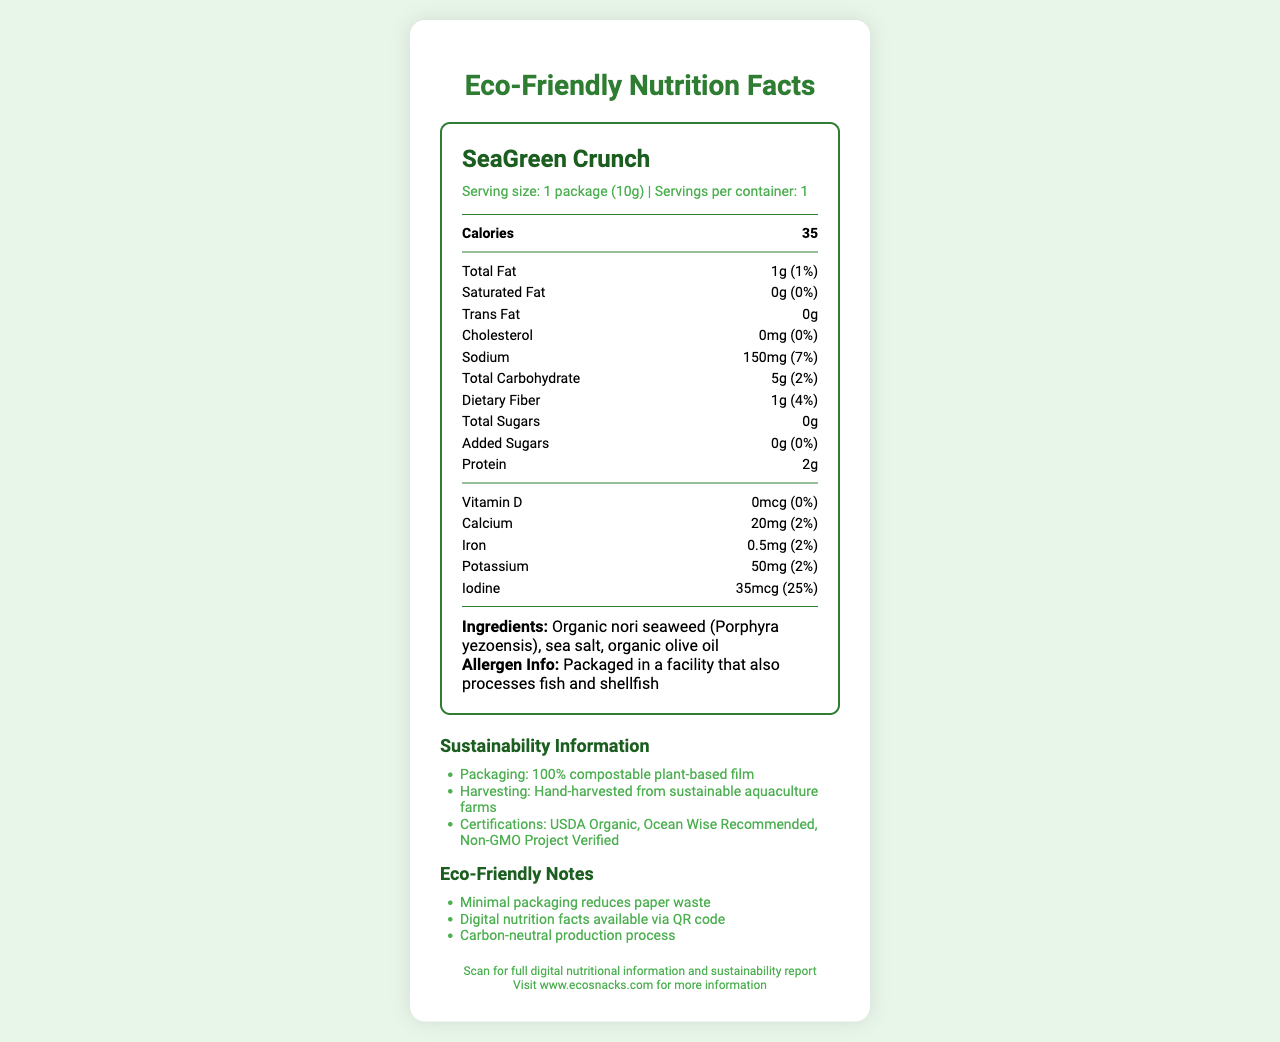What is the serving size of SeaGreen Crunch? The serving size is stated at the beginning of the document: "Serving size: 1 package (10g)."
Answer: 1 package (10g) How many calories does one serving of SeaGreen Crunch have? The calories amount is provided in the nutrients section: "Calories 35."
Answer: 35 calories How much sodium is in one serving of SeaGreen Crunch? The sodium content is detailed in the nutrients section: "Sodium 150mg (7%)."
Answer: 150mg What are the main ingredients in SeaGreen Crunch? The ingredients list states: "Ingredients: Organic nori seaweed (Porphyra yezoensis), sea salt, organic olive oil."
Answer: Organic nori seaweed (Porphyra yezoensis), sea salt, organic olive oil Does SeaGreen Crunch contain any added sugars? The label specifies: "Added Sugars: 0g (0%)."
Answer: No What is the daily value of iron in SeaGreen Crunch? A. 0% B. 2% C. 7% D. 4% The nutrients section lists iron with a daily value of 2%, thus option B is correct: "Iron 0.5mg (2%)."
Answer: B. 2% Which of the following certifications does SeaGreen Crunch have? I. USDA Organic II. Fair Trade III. Ocean Wise Recommended IV. Non-GMO Project Verified SeaGreen Crunch has the certifications "USDA Organic", "Ocean Wise Recommended", and "Non-GMO Project Verified."
Answer: I, III, IV Is the packaging of SeaGreen Crunch compostable? The sustainability information section mentions: "Packaging: 100% compostable plant-based film."
Answer: Yes Summarize the main purpose of this document. This document details the nutritional contents of SeaGreen Crunch, including calories, fats, sodium, carbohydrates, fiber, and sugars. It also lists ingredients, allergen information, and certifications such as USDA Organic and Non-GMO Project Verified. Additionally, the document emphasizes the product's eco-friendly aspects, like compostable packaging and carbon-neutral production.
Answer: It provides the nutritional facts and sustainability information for SeaGreen Crunch, highlighting its minimal packaging, compostable materials, and various certifications. How is SeaGreen Crunch harvested? The sustainability information section specifies the harvesting method: "Hand-harvested from sustainable aquaculture farms."
Answer: Hand-harvested from sustainable aquaculture farms What company produces SeaGreen Crunch? The company information at the end of the document states the producer: "Company: EcoSnacks Co."
Answer: EcoSnacks Co. What nutritional benefits does SeaGreen Crunch provide? The document highlights various nutrients beneficial to human health, including: "Dietary Fiber 1g (4%), Protein 2g, Iodine 35mcg (25%), Calcium 20mg (2%), Iron 0.5mg (2%)."
Answer: Dietary fiber, protein, iodine, calcium, and iron Who processes SeaGreen Crunch and what potential allergen risks exist? The allergen information section indicates where it's processed and potential allergens: "Packaged in a facility that also processes fish and shellfish."
Answer: Packaged in a facility that also processes fish and shellfish Can you determine the carbon footprint of SeaGreen Crunch's production? The document mentions carbon-neutral production but does not provide specific details about the carbon footprint: "Carbon-neutral production process."
Answer: No 